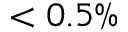Convert formula to latex. <formula><loc_0><loc_0><loc_500><loc_500>< 0 . 5 \%</formula> 